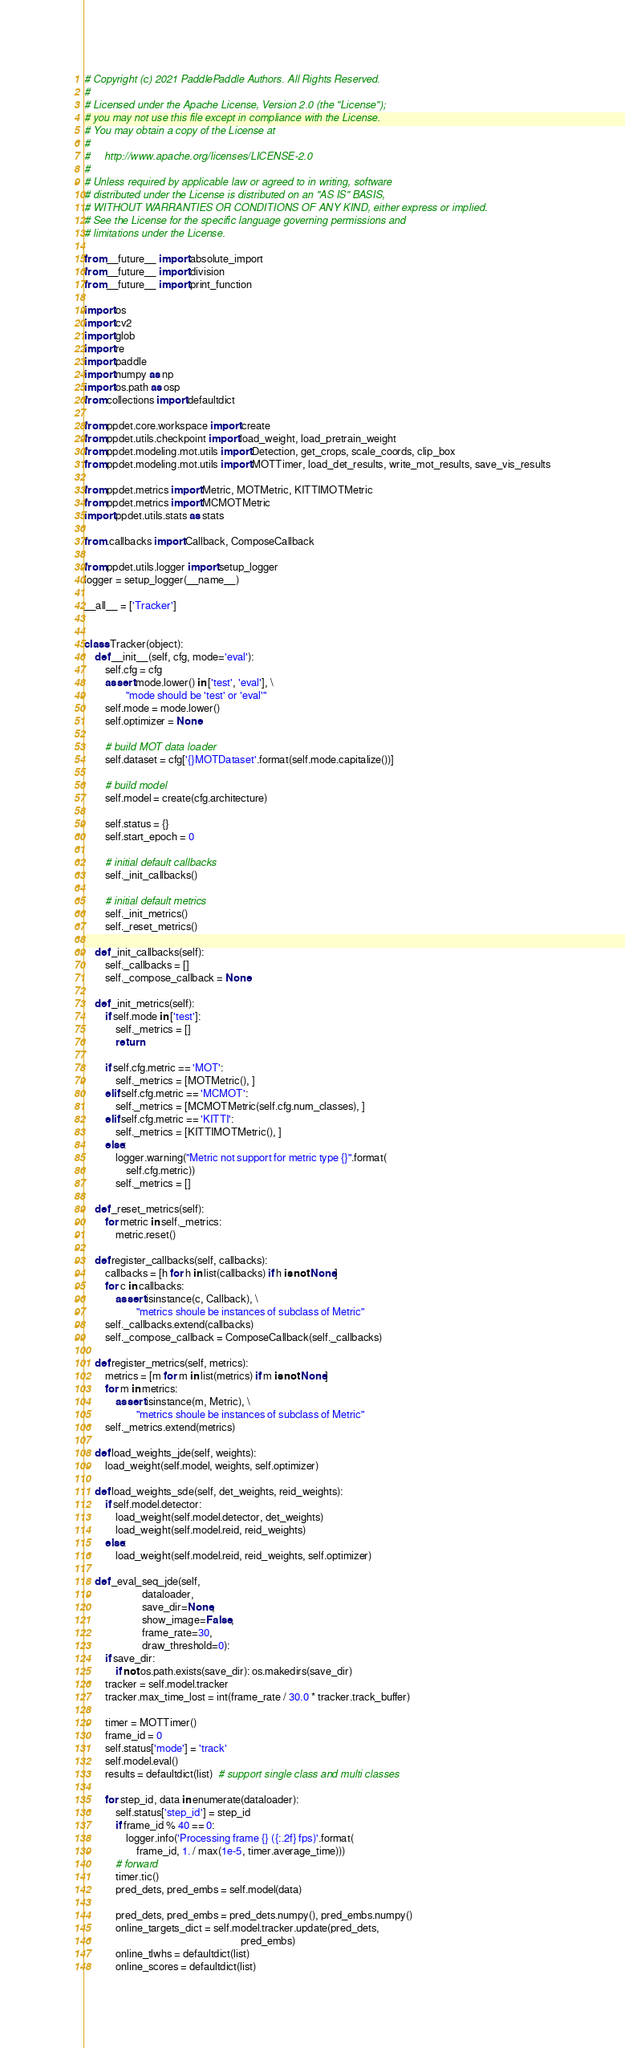Convert code to text. <code><loc_0><loc_0><loc_500><loc_500><_Python_># Copyright (c) 2021 PaddlePaddle Authors. All Rights Reserved.
#
# Licensed under the Apache License, Version 2.0 (the "License");
# you may not use this file except in compliance with the License.
# You may obtain a copy of the License at
#
#     http://www.apache.org/licenses/LICENSE-2.0
#
# Unless required by applicable law or agreed to in writing, software
# distributed under the License is distributed on an "AS IS" BASIS,
# WITHOUT WARRANTIES OR CONDITIONS OF ANY KIND, either express or implied.
# See the License for the specific language governing permissions and
# limitations under the License.

from __future__ import absolute_import
from __future__ import division
from __future__ import print_function

import os
import cv2
import glob
import re
import paddle
import numpy as np
import os.path as osp
from collections import defaultdict

from ppdet.core.workspace import create
from ppdet.utils.checkpoint import load_weight, load_pretrain_weight
from ppdet.modeling.mot.utils import Detection, get_crops, scale_coords, clip_box
from ppdet.modeling.mot.utils import MOTTimer, load_det_results, write_mot_results, save_vis_results

from ppdet.metrics import Metric, MOTMetric, KITTIMOTMetric
from ppdet.metrics import MCMOTMetric
import ppdet.utils.stats as stats

from .callbacks import Callback, ComposeCallback

from ppdet.utils.logger import setup_logger
logger = setup_logger(__name__)

__all__ = ['Tracker']


class Tracker(object):
    def __init__(self, cfg, mode='eval'):
        self.cfg = cfg
        assert mode.lower() in ['test', 'eval'], \
                "mode should be 'test' or 'eval'"
        self.mode = mode.lower()
        self.optimizer = None

        # build MOT data loader
        self.dataset = cfg['{}MOTDataset'.format(self.mode.capitalize())]

        # build model
        self.model = create(cfg.architecture)

        self.status = {}
        self.start_epoch = 0

        # initial default callbacks
        self._init_callbacks()

        # initial default metrics
        self._init_metrics()
        self._reset_metrics()

    def _init_callbacks(self):
        self._callbacks = []
        self._compose_callback = None

    def _init_metrics(self):
        if self.mode in ['test']:
            self._metrics = []
            return

        if self.cfg.metric == 'MOT':
            self._metrics = [MOTMetric(), ]
        elif self.cfg.metric == 'MCMOT':
            self._metrics = [MCMOTMetric(self.cfg.num_classes), ]
        elif self.cfg.metric == 'KITTI':
            self._metrics = [KITTIMOTMetric(), ]
        else:
            logger.warning("Metric not support for metric type {}".format(
                self.cfg.metric))
            self._metrics = []

    def _reset_metrics(self):
        for metric in self._metrics:
            metric.reset()

    def register_callbacks(self, callbacks):
        callbacks = [h for h in list(callbacks) if h is not None]
        for c in callbacks:
            assert isinstance(c, Callback), \
                    "metrics shoule be instances of subclass of Metric"
        self._callbacks.extend(callbacks)
        self._compose_callback = ComposeCallback(self._callbacks)

    def register_metrics(self, metrics):
        metrics = [m for m in list(metrics) if m is not None]
        for m in metrics:
            assert isinstance(m, Metric), \
                    "metrics shoule be instances of subclass of Metric"
        self._metrics.extend(metrics)

    def load_weights_jde(self, weights):
        load_weight(self.model, weights, self.optimizer)

    def load_weights_sde(self, det_weights, reid_weights):
        if self.model.detector:
            load_weight(self.model.detector, det_weights)
            load_weight(self.model.reid, reid_weights)
        else:
            load_weight(self.model.reid, reid_weights, self.optimizer)

    def _eval_seq_jde(self,
                      dataloader,
                      save_dir=None,
                      show_image=False,
                      frame_rate=30,
                      draw_threshold=0):
        if save_dir:
            if not os.path.exists(save_dir): os.makedirs(save_dir)
        tracker = self.model.tracker
        tracker.max_time_lost = int(frame_rate / 30.0 * tracker.track_buffer)

        timer = MOTTimer()
        frame_id = 0
        self.status['mode'] = 'track'
        self.model.eval()
        results = defaultdict(list)  # support single class and multi classes

        for step_id, data in enumerate(dataloader):
            self.status['step_id'] = step_id
            if frame_id % 40 == 0:
                logger.info('Processing frame {} ({:.2f} fps)'.format(
                    frame_id, 1. / max(1e-5, timer.average_time)))
            # forward
            timer.tic()
            pred_dets, pred_embs = self.model(data)

            pred_dets, pred_embs = pred_dets.numpy(), pred_embs.numpy()
            online_targets_dict = self.model.tracker.update(pred_dets,
                                                            pred_embs)
            online_tlwhs = defaultdict(list)
            online_scores = defaultdict(list)</code> 